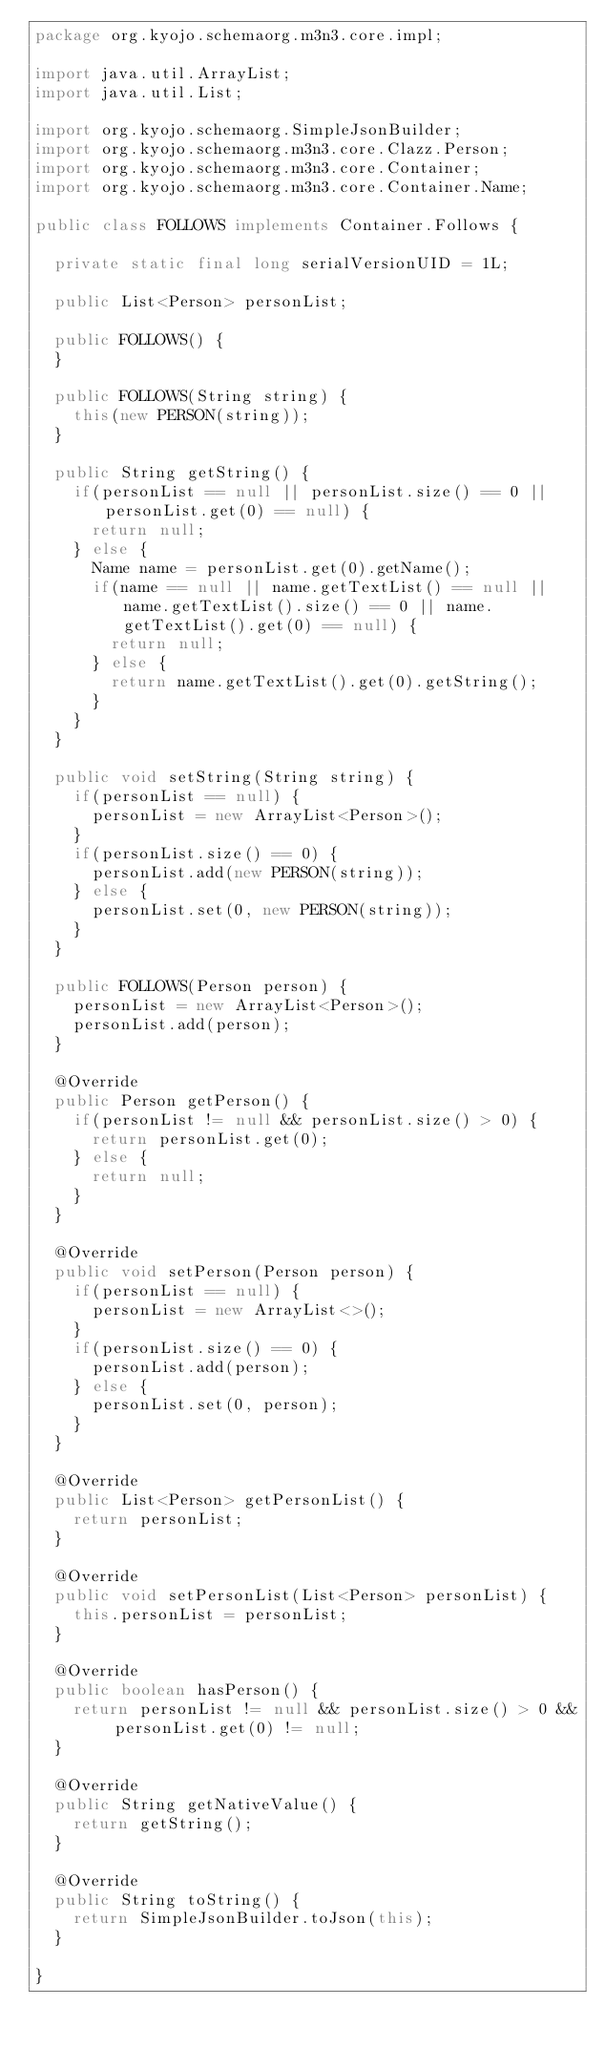Convert code to text. <code><loc_0><loc_0><loc_500><loc_500><_Java_>package org.kyojo.schemaorg.m3n3.core.impl;

import java.util.ArrayList;
import java.util.List;

import org.kyojo.schemaorg.SimpleJsonBuilder;
import org.kyojo.schemaorg.m3n3.core.Clazz.Person;
import org.kyojo.schemaorg.m3n3.core.Container;
import org.kyojo.schemaorg.m3n3.core.Container.Name;

public class FOLLOWS implements Container.Follows {

	private static final long serialVersionUID = 1L;

	public List<Person> personList;

	public FOLLOWS() {
	}

	public FOLLOWS(String string) {
		this(new PERSON(string));
	}

	public String getString() {
		if(personList == null || personList.size() == 0 || personList.get(0) == null) {
			return null;
		} else {
			Name name = personList.get(0).getName();
			if(name == null || name.getTextList() == null || name.getTextList().size() == 0 || name.getTextList().get(0) == null) {
				return null;
			} else {
				return name.getTextList().get(0).getString();
			}
		}
	}

	public void setString(String string) {
		if(personList == null) {
			personList = new ArrayList<Person>();
		}
		if(personList.size() == 0) {
			personList.add(new PERSON(string));
		} else {
			personList.set(0, new PERSON(string));
		}
	}

	public FOLLOWS(Person person) {
		personList = new ArrayList<Person>();
		personList.add(person);
	}

	@Override
	public Person getPerson() {
		if(personList != null && personList.size() > 0) {
			return personList.get(0);
		} else {
			return null;
		}
	}

	@Override
	public void setPerson(Person person) {
		if(personList == null) {
			personList = new ArrayList<>();
		}
		if(personList.size() == 0) {
			personList.add(person);
		} else {
			personList.set(0, person);
		}
	}

	@Override
	public List<Person> getPersonList() {
		return personList;
	}

	@Override
	public void setPersonList(List<Person> personList) {
		this.personList = personList;
	}

	@Override
	public boolean hasPerson() {
		return personList != null && personList.size() > 0 && personList.get(0) != null;
	}

	@Override
	public String getNativeValue() {
		return getString();
	}

	@Override
	public String toString() {
		return SimpleJsonBuilder.toJson(this);
	}

}
</code> 